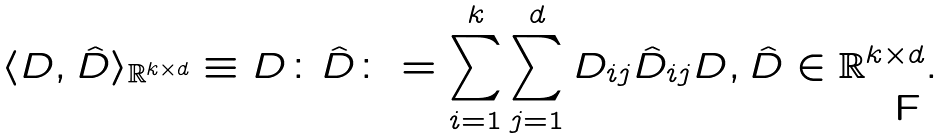Convert formula to latex. <formula><loc_0><loc_0><loc_500><loc_500>\langle D , \hat { D } \rangle _ { \mathbb { R } ^ { k \times d } } \equiv D \colon \hat { D } \colon = \sum _ { i = 1 } ^ { k } \sum _ { j = 1 } ^ { d } D _ { i j } \hat { D } _ { i j } D , \hat { D } \in \mathbb { R } ^ { k \times d } .</formula> 